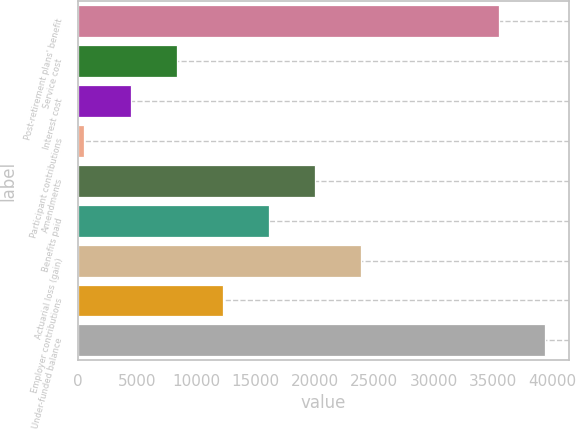<chart> <loc_0><loc_0><loc_500><loc_500><bar_chart><fcel>Post-retirement plans' benefit<fcel>Service cost<fcel>Interest cost<fcel>Participant contributions<fcel>Amendments<fcel>Benefits paid<fcel>Actuarial loss (gain)<fcel>Employer contributions<fcel>Under-funded balance<nl><fcel>35534.4<fcel>8342.2<fcel>4457.6<fcel>573<fcel>19996<fcel>16111.4<fcel>23880.6<fcel>12226.8<fcel>39419<nl></chart> 